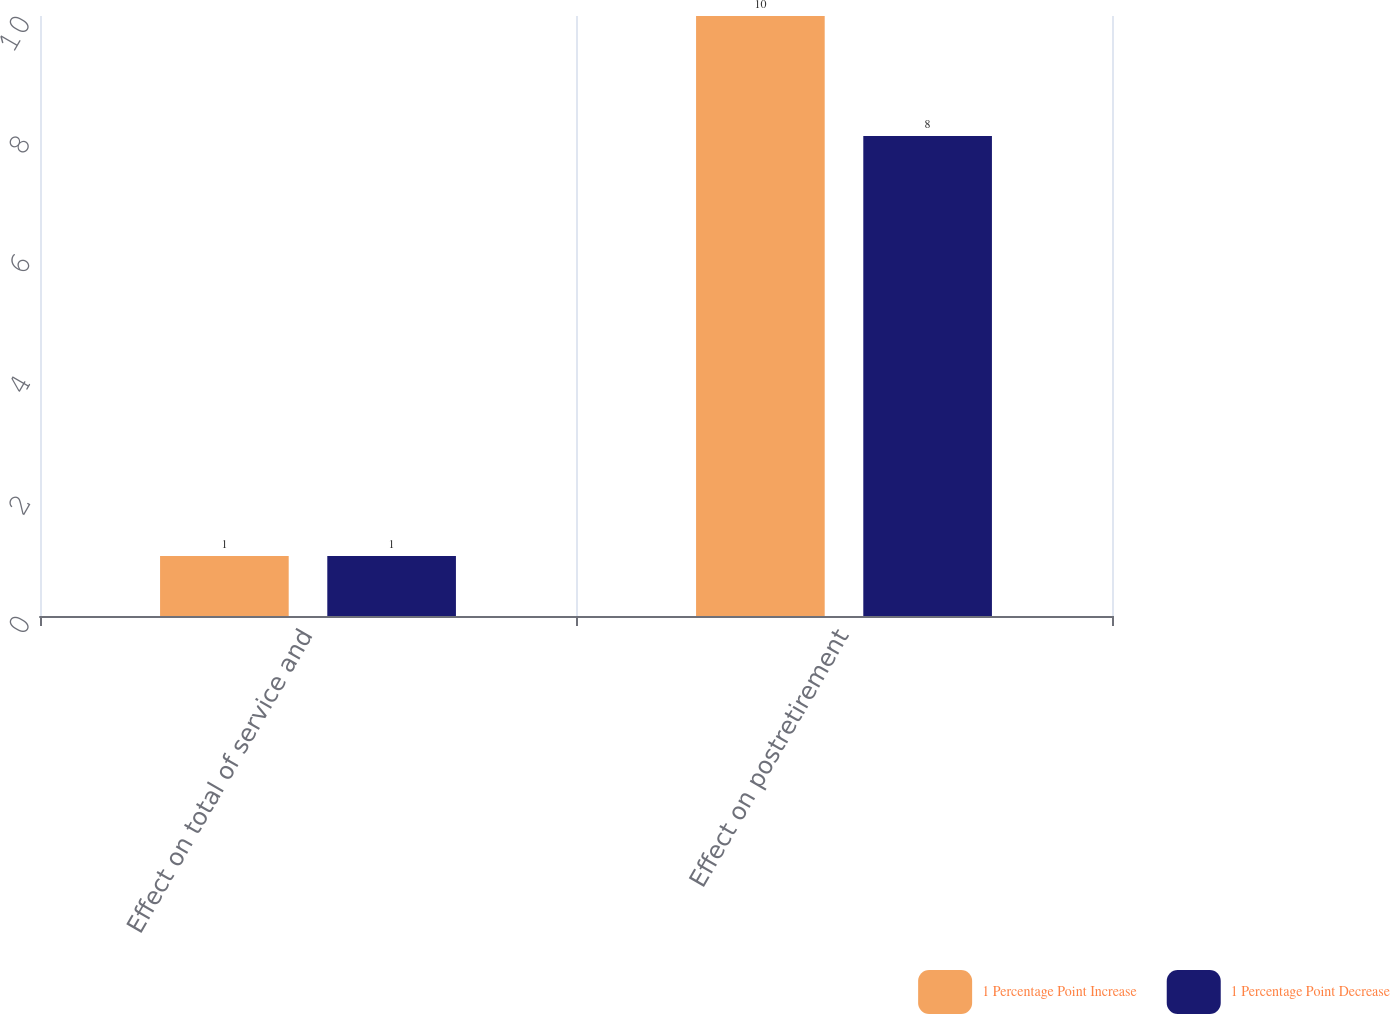Convert chart. <chart><loc_0><loc_0><loc_500><loc_500><stacked_bar_chart><ecel><fcel>Effect on total of service and<fcel>Effect on postretirement<nl><fcel>1 Percentage Point Increase<fcel>1<fcel>10<nl><fcel>1 Percentage Point Decrease<fcel>1<fcel>8<nl></chart> 